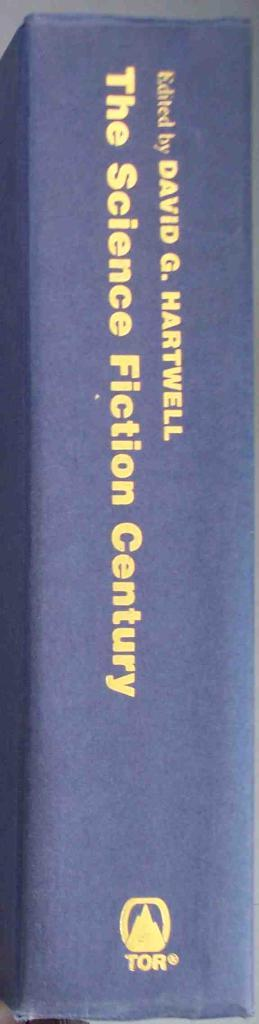<image>
Write a terse but informative summary of the picture. The Science Fiction Century by David G. Hartwell sits on a shelf. 